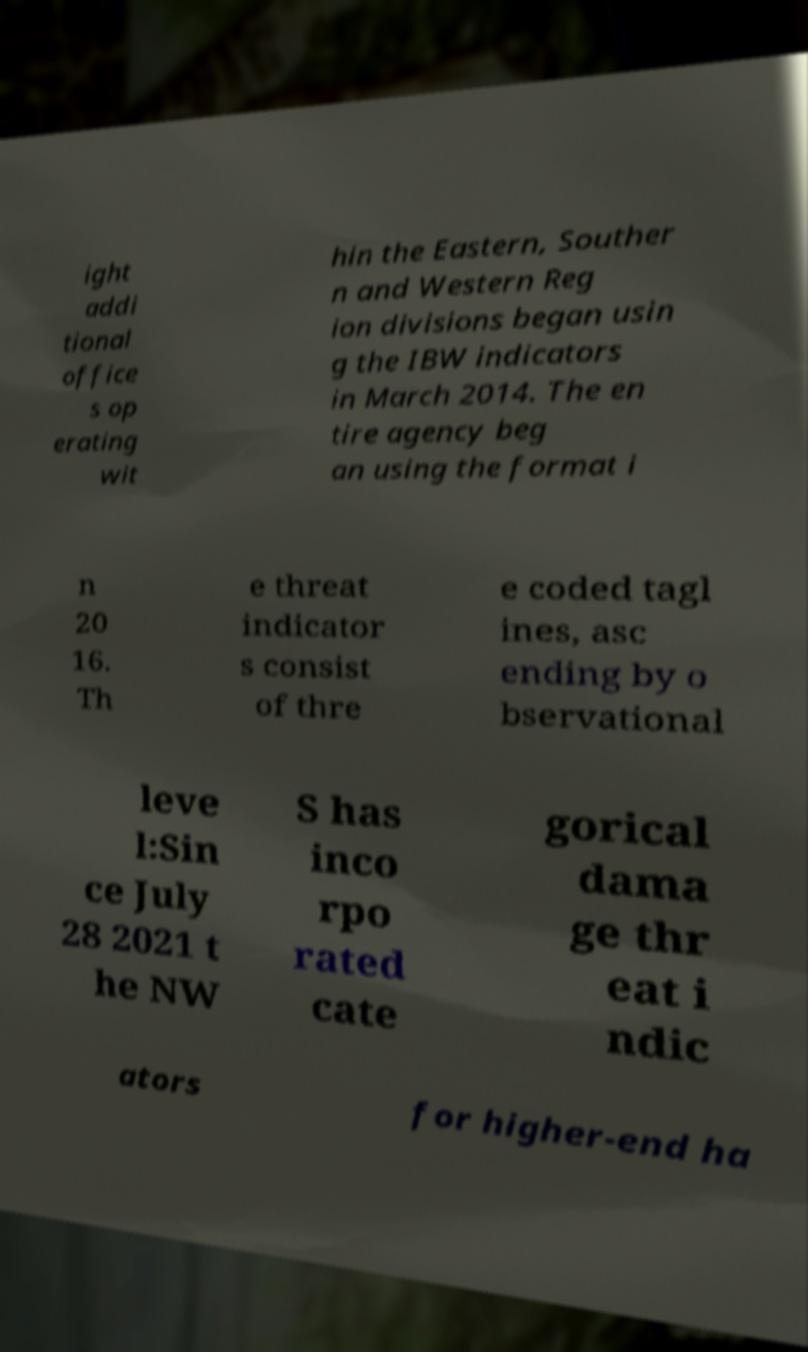Can you accurately transcribe the text from the provided image for me? ight addi tional office s op erating wit hin the Eastern, Souther n and Western Reg ion divisions began usin g the IBW indicators in March 2014. The en tire agency beg an using the format i n 20 16. Th e threat indicator s consist of thre e coded tagl ines, asc ending by o bservational leve l:Sin ce July 28 2021 t he NW S has inco rpo rated cate gorical dama ge thr eat i ndic ators for higher-end ha 